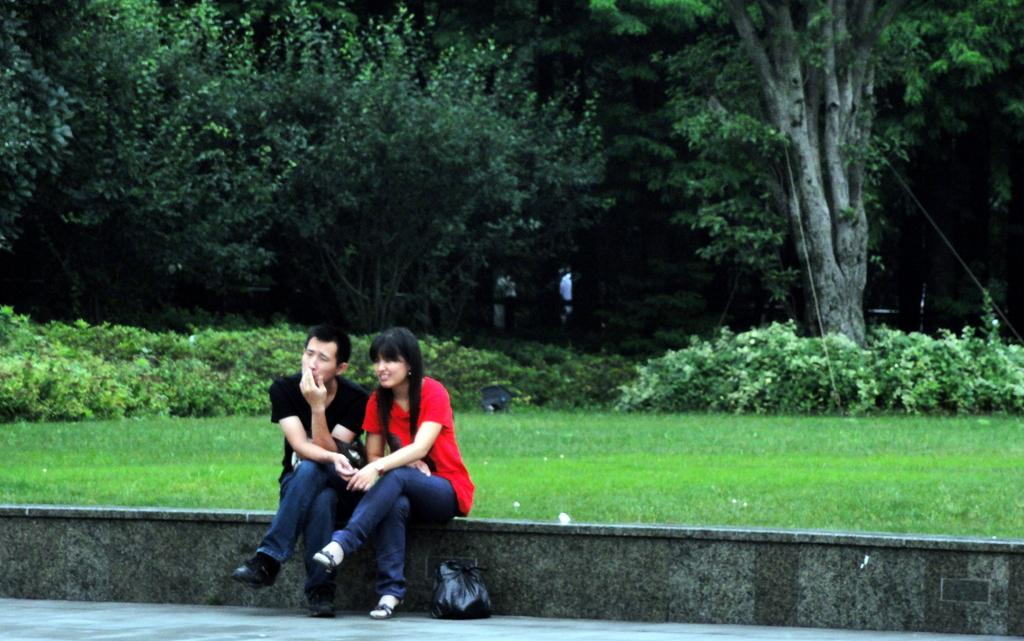How many people are present in the image? There are two people, a man and a woman, present in the image. What are the positions of the man and woman in the image? Both the man and woman are sitting in the image. What type of natural environment is visible in the image? There is grass, plants, and trees visible in the image. What type of boundary can be seen between the man and woman in the image? There is no boundary visible between the man and woman in the image. What type of cap is the achiever wearing in the image? There is no achiever present in the image, and therefore no cap can be observed. 